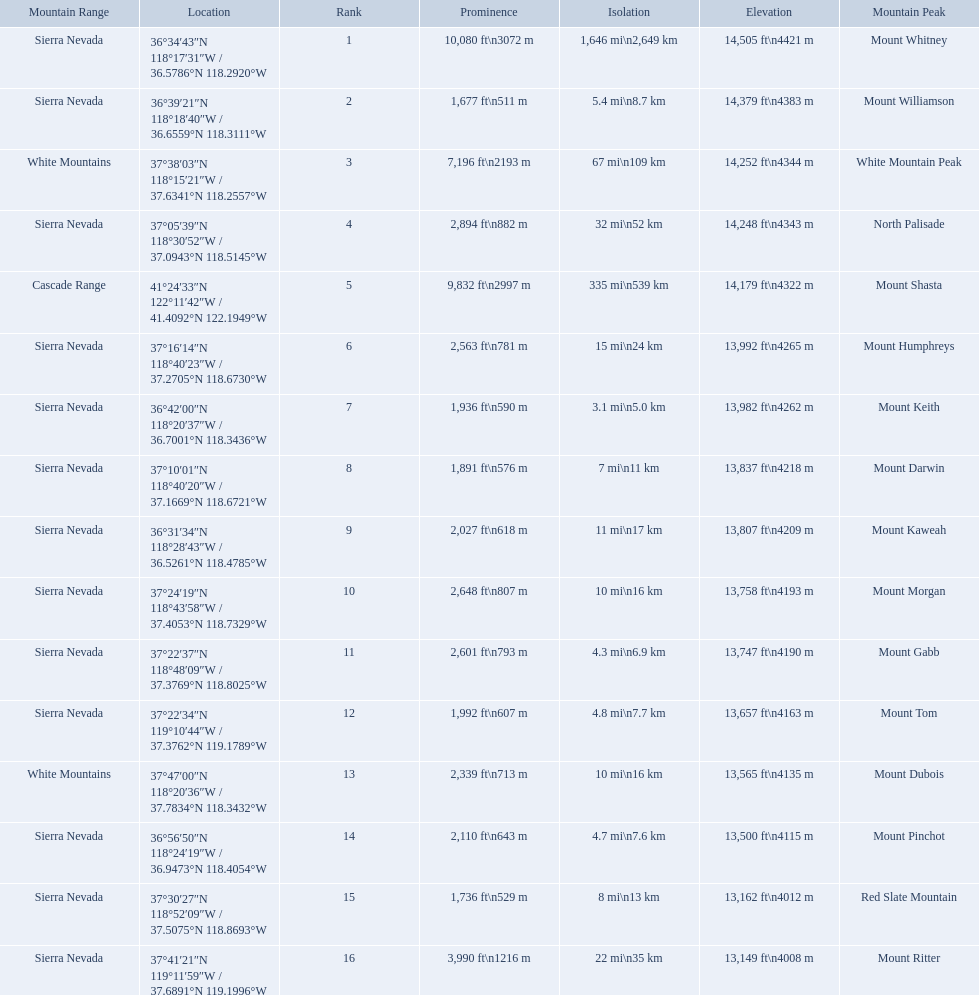What are the peaks in california? Mount Whitney, Mount Williamson, White Mountain Peak, North Palisade, Mount Shasta, Mount Humphreys, Mount Keith, Mount Darwin, Mount Kaweah, Mount Morgan, Mount Gabb, Mount Tom, Mount Dubois, Mount Pinchot, Red Slate Mountain, Mount Ritter. What are the peaks in sierra nevada, california? Mount Whitney, Mount Williamson, North Palisade, Mount Humphreys, Mount Keith, Mount Darwin, Mount Kaweah, Mount Morgan, Mount Gabb, Mount Tom, Mount Pinchot, Red Slate Mountain, Mount Ritter. What are the heights of the peaks in sierra nevada? 14,505 ft\n4421 m, 14,379 ft\n4383 m, 14,248 ft\n4343 m, 13,992 ft\n4265 m, 13,982 ft\n4262 m, 13,837 ft\n4218 m, 13,807 ft\n4209 m, 13,758 ft\n4193 m, 13,747 ft\n4190 m, 13,657 ft\n4163 m, 13,500 ft\n4115 m, 13,162 ft\n4012 m, 13,149 ft\n4008 m. Which is the highest? Mount Whitney. 